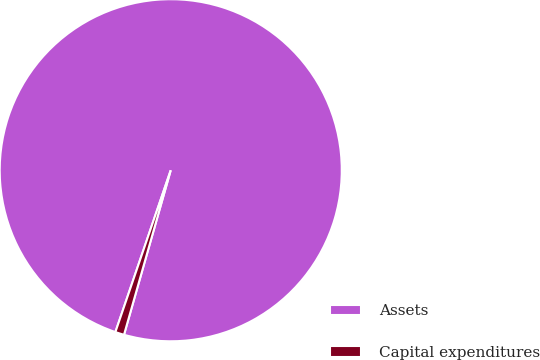<chart> <loc_0><loc_0><loc_500><loc_500><pie_chart><fcel>Assets<fcel>Capital expenditures<nl><fcel>99.16%<fcel>0.84%<nl></chart> 